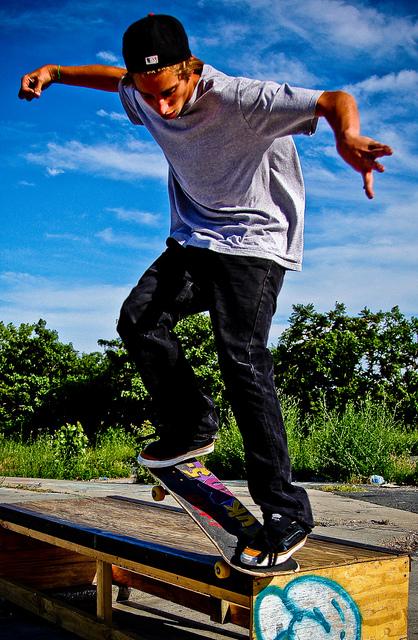Is the man wearing knee pads?
Quick response, please. No. How much safety protection is he wearing?
Concise answer only. 0. Is the male jumping from a wooden bench?
Write a very short answer. Yes. What color is his hat?
Concise answer only. Black. Is the border jumping wearing a helmet?
Keep it brief. No. Is this a modern day photo?
Answer briefly. Yes. What is this guy doing?
Keep it brief. Skateboarding. 